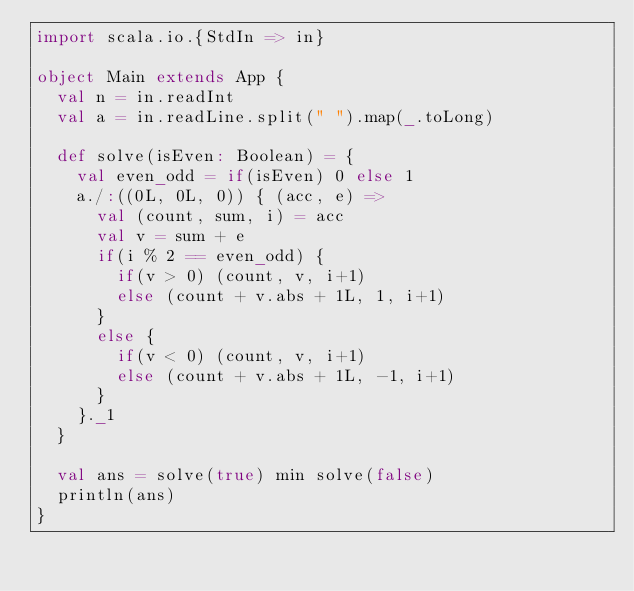Convert code to text. <code><loc_0><loc_0><loc_500><loc_500><_Scala_>import scala.io.{StdIn => in}

object Main extends App {
  val n = in.readInt
  val a = in.readLine.split(" ").map(_.toLong)

  def solve(isEven: Boolean) = {
    val even_odd = if(isEven) 0 else 1
    a./:((0L, 0L, 0)) { (acc, e) =>
      val (count, sum, i) = acc
      val v = sum + e
      if(i % 2 == even_odd) {
        if(v > 0) (count, v, i+1)
        else (count + v.abs + 1L, 1, i+1)
      }
      else {
        if(v < 0) (count, v, i+1)
        else (count + v.abs + 1L, -1, i+1)
      }
    }._1
  }

  val ans = solve(true) min solve(false)
  println(ans)
}</code> 